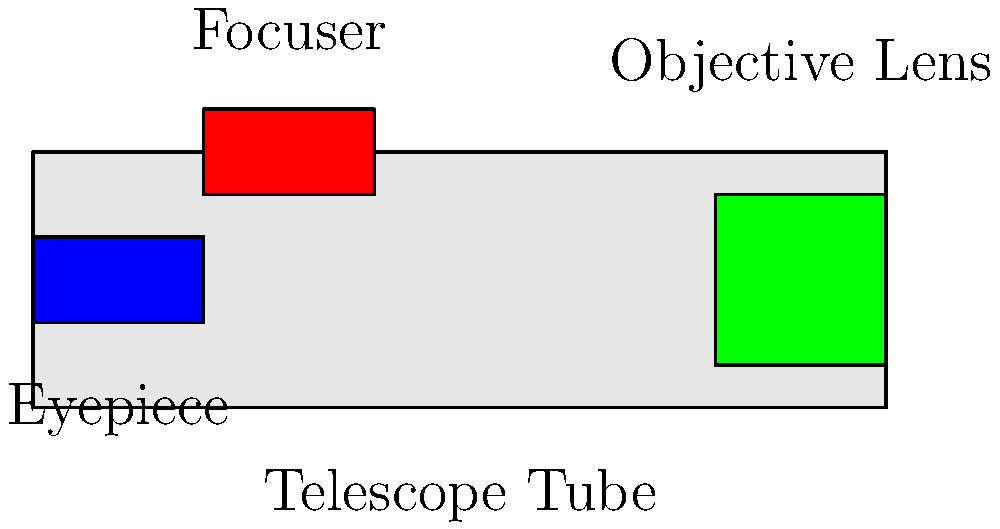In this basic telescope diagram, what part helps you adjust the sharpness of the image you see? Let's break down the parts of the telescope in the diagram:

1. Eyepiece: This is where you look through to see the magnified image. It's colored blue in the diagram.
2. Objective Lens: This is the large lens at the front of the telescope that gathers light from distant objects. It's colored green in the diagram.
3. Telescope Tube: This is the main body of the telescope that holds all the parts together. It's colored light gray in the diagram.
4. Focuser: This is the part colored red in the diagram, located near the eyepiece.

The focuser is the key to adjusting the sharpness of the image. When you turn the focuser, it moves the eyepiece slightly closer to or farther from the objective lens. This adjustment helps bring the image into clear focus, making it sharp and crisp.

Think of it like adjusting the focus on a camera or a pair of binoculars. The focuser helps you find that perfect spot where everything looks clear and not blurry.
Answer: Focuser 